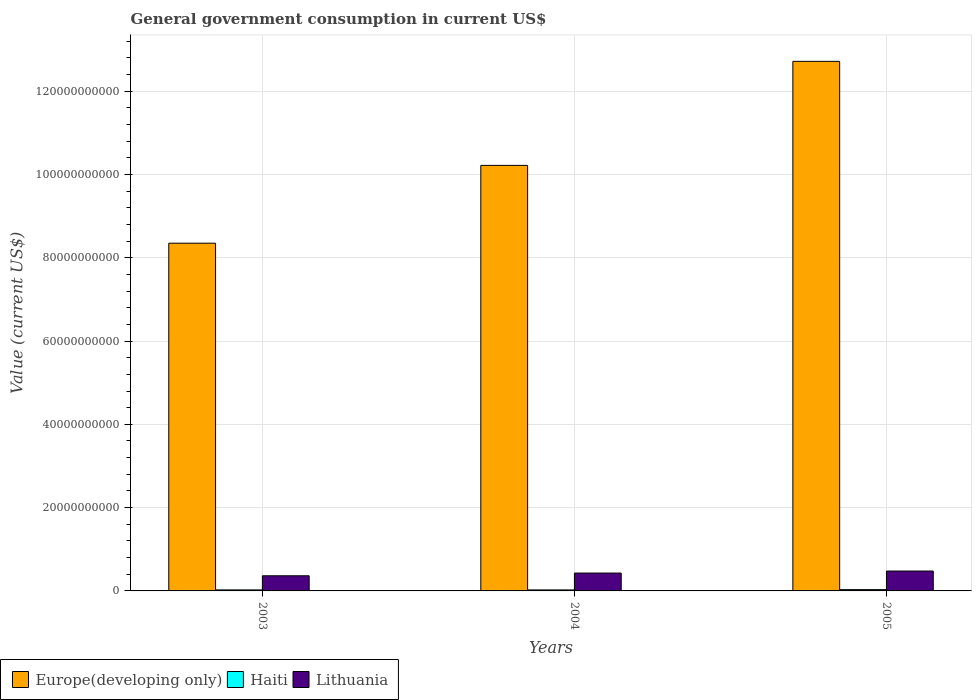How many different coloured bars are there?
Ensure brevity in your answer.  3. What is the government conusmption in Haiti in 2003?
Ensure brevity in your answer.  2.46e+08. Across all years, what is the maximum government conusmption in Europe(developing only)?
Your answer should be compact. 1.27e+11. Across all years, what is the minimum government conusmption in Lithuania?
Offer a terse response. 3.64e+09. In which year was the government conusmption in Europe(developing only) minimum?
Give a very brief answer. 2003. What is the total government conusmption in Lithuania in the graph?
Ensure brevity in your answer.  1.27e+1. What is the difference between the government conusmption in Europe(developing only) in 2003 and that in 2005?
Offer a terse response. -4.37e+1. What is the difference between the government conusmption in Haiti in 2005 and the government conusmption in Lithuania in 2003?
Your answer should be compact. -3.32e+09. What is the average government conusmption in Haiti per year?
Provide a succinct answer. 2.67e+08. In the year 2003, what is the difference between the government conusmption in Europe(developing only) and government conusmption in Lithuania?
Your answer should be very brief. 7.99e+1. In how many years, is the government conusmption in Europe(developing only) greater than 84000000000 US$?
Give a very brief answer. 2. What is the ratio of the government conusmption in Haiti in 2003 to that in 2004?
Your answer should be very brief. 1.02. Is the government conusmption in Haiti in 2004 less than that in 2005?
Your response must be concise. Yes. Is the difference between the government conusmption in Europe(developing only) in 2004 and 2005 greater than the difference between the government conusmption in Lithuania in 2004 and 2005?
Make the answer very short. No. What is the difference between the highest and the second highest government conusmption in Haiti?
Your answer should be very brief. 6.87e+07. What is the difference between the highest and the lowest government conusmption in Haiti?
Your answer should be compact. 7.45e+07. In how many years, is the government conusmption in Lithuania greater than the average government conusmption in Lithuania taken over all years?
Provide a short and direct response. 2. What does the 3rd bar from the left in 2005 represents?
Offer a very short reply. Lithuania. What does the 2nd bar from the right in 2003 represents?
Keep it short and to the point. Haiti. Is it the case that in every year, the sum of the government conusmption in Haiti and government conusmption in Europe(developing only) is greater than the government conusmption in Lithuania?
Provide a short and direct response. Yes. Are all the bars in the graph horizontal?
Make the answer very short. No. How many years are there in the graph?
Provide a succinct answer. 3. What is the difference between two consecutive major ticks on the Y-axis?
Your response must be concise. 2.00e+1. Are the values on the major ticks of Y-axis written in scientific E-notation?
Your response must be concise. No. Does the graph contain any zero values?
Offer a terse response. No. Does the graph contain grids?
Your answer should be compact. Yes. How many legend labels are there?
Offer a terse response. 3. What is the title of the graph?
Offer a terse response. General government consumption in current US$. Does "East Asia (all income levels)" appear as one of the legend labels in the graph?
Ensure brevity in your answer.  No. What is the label or title of the X-axis?
Provide a short and direct response. Years. What is the label or title of the Y-axis?
Keep it short and to the point. Value (current US$). What is the Value (current US$) in Europe(developing only) in 2003?
Your answer should be very brief. 8.35e+1. What is the Value (current US$) in Haiti in 2003?
Ensure brevity in your answer.  2.46e+08. What is the Value (current US$) in Lithuania in 2003?
Give a very brief answer. 3.64e+09. What is the Value (current US$) of Europe(developing only) in 2004?
Your response must be concise. 1.02e+11. What is the Value (current US$) in Haiti in 2004?
Your answer should be compact. 2.40e+08. What is the Value (current US$) in Lithuania in 2004?
Your answer should be compact. 4.29e+09. What is the Value (current US$) of Europe(developing only) in 2005?
Offer a terse response. 1.27e+11. What is the Value (current US$) in Haiti in 2005?
Offer a terse response. 3.15e+08. What is the Value (current US$) of Lithuania in 2005?
Offer a very short reply. 4.78e+09. Across all years, what is the maximum Value (current US$) in Europe(developing only)?
Make the answer very short. 1.27e+11. Across all years, what is the maximum Value (current US$) of Haiti?
Ensure brevity in your answer.  3.15e+08. Across all years, what is the maximum Value (current US$) in Lithuania?
Your answer should be very brief. 4.78e+09. Across all years, what is the minimum Value (current US$) in Europe(developing only)?
Offer a very short reply. 8.35e+1. Across all years, what is the minimum Value (current US$) of Haiti?
Offer a terse response. 2.40e+08. Across all years, what is the minimum Value (current US$) of Lithuania?
Keep it short and to the point. 3.64e+09. What is the total Value (current US$) in Europe(developing only) in the graph?
Provide a succinct answer. 3.13e+11. What is the total Value (current US$) in Haiti in the graph?
Make the answer very short. 8.01e+08. What is the total Value (current US$) in Lithuania in the graph?
Give a very brief answer. 1.27e+1. What is the difference between the Value (current US$) in Europe(developing only) in 2003 and that in 2004?
Offer a very short reply. -1.87e+1. What is the difference between the Value (current US$) of Haiti in 2003 and that in 2004?
Offer a terse response. 5.73e+06. What is the difference between the Value (current US$) of Lithuania in 2003 and that in 2004?
Offer a very short reply. -6.56e+08. What is the difference between the Value (current US$) in Europe(developing only) in 2003 and that in 2005?
Your response must be concise. -4.37e+1. What is the difference between the Value (current US$) in Haiti in 2003 and that in 2005?
Offer a very short reply. -6.87e+07. What is the difference between the Value (current US$) in Lithuania in 2003 and that in 2005?
Keep it short and to the point. -1.14e+09. What is the difference between the Value (current US$) of Europe(developing only) in 2004 and that in 2005?
Your answer should be very brief. -2.50e+1. What is the difference between the Value (current US$) in Haiti in 2004 and that in 2005?
Offer a very short reply. -7.45e+07. What is the difference between the Value (current US$) in Lithuania in 2004 and that in 2005?
Make the answer very short. -4.83e+08. What is the difference between the Value (current US$) in Europe(developing only) in 2003 and the Value (current US$) in Haiti in 2004?
Your answer should be very brief. 8.33e+1. What is the difference between the Value (current US$) in Europe(developing only) in 2003 and the Value (current US$) in Lithuania in 2004?
Ensure brevity in your answer.  7.92e+1. What is the difference between the Value (current US$) of Haiti in 2003 and the Value (current US$) of Lithuania in 2004?
Keep it short and to the point. -4.05e+09. What is the difference between the Value (current US$) of Europe(developing only) in 2003 and the Value (current US$) of Haiti in 2005?
Keep it short and to the point. 8.32e+1. What is the difference between the Value (current US$) of Europe(developing only) in 2003 and the Value (current US$) of Lithuania in 2005?
Your answer should be compact. 7.87e+1. What is the difference between the Value (current US$) of Haiti in 2003 and the Value (current US$) of Lithuania in 2005?
Offer a terse response. -4.53e+09. What is the difference between the Value (current US$) of Europe(developing only) in 2004 and the Value (current US$) of Haiti in 2005?
Your response must be concise. 1.02e+11. What is the difference between the Value (current US$) of Europe(developing only) in 2004 and the Value (current US$) of Lithuania in 2005?
Your answer should be compact. 9.74e+1. What is the difference between the Value (current US$) in Haiti in 2004 and the Value (current US$) in Lithuania in 2005?
Provide a short and direct response. -4.53e+09. What is the average Value (current US$) in Europe(developing only) per year?
Ensure brevity in your answer.  1.04e+11. What is the average Value (current US$) in Haiti per year?
Give a very brief answer. 2.67e+08. What is the average Value (current US$) in Lithuania per year?
Your response must be concise. 4.23e+09. In the year 2003, what is the difference between the Value (current US$) of Europe(developing only) and Value (current US$) of Haiti?
Your response must be concise. 8.33e+1. In the year 2003, what is the difference between the Value (current US$) of Europe(developing only) and Value (current US$) of Lithuania?
Provide a short and direct response. 7.99e+1. In the year 2003, what is the difference between the Value (current US$) in Haiti and Value (current US$) in Lithuania?
Your answer should be compact. -3.39e+09. In the year 2004, what is the difference between the Value (current US$) in Europe(developing only) and Value (current US$) in Haiti?
Give a very brief answer. 1.02e+11. In the year 2004, what is the difference between the Value (current US$) in Europe(developing only) and Value (current US$) in Lithuania?
Your response must be concise. 9.79e+1. In the year 2004, what is the difference between the Value (current US$) of Haiti and Value (current US$) of Lithuania?
Your answer should be very brief. -4.05e+09. In the year 2005, what is the difference between the Value (current US$) of Europe(developing only) and Value (current US$) of Haiti?
Provide a succinct answer. 1.27e+11. In the year 2005, what is the difference between the Value (current US$) in Europe(developing only) and Value (current US$) in Lithuania?
Keep it short and to the point. 1.22e+11. In the year 2005, what is the difference between the Value (current US$) of Haiti and Value (current US$) of Lithuania?
Keep it short and to the point. -4.46e+09. What is the ratio of the Value (current US$) of Europe(developing only) in 2003 to that in 2004?
Your answer should be very brief. 0.82. What is the ratio of the Value (current US$) in Haiti in 2003 to that in 2004?
Keep it short and to the point. 1.02. What is the ratio of the Value (current US$) in Lithuania in 2003 to that in 2004?
Make the answer very short. 0.85. What is the ratio of the Value (current US$) of Europe(developing only) in 2003 to that in 2005?
Keep it short and to the point. 0.66. What is the ratio of the Value (current US$) of Haiti in 2003 to that in 2005?
Provide a short and direct response. 0.78. What is the ratio of the Value (current US$) of Lithuania in 2003 to that in 2005?
Ensure brevity in your answer.  0.76. What is the ratio of the Value (current US$) in Europe(developing only) in 2004 to that in 2005?
Make the answer very short. 0.8. What is the ratio of the Value (current US$) of Haiti in 2004 to that in 2005?
Give a very brief answer. 0.76. What is the ratio of the Value (current US$) of Lithuania in 2004 to that in 2005?
Offer a terse response. 0.9. What is the difference between the highest and the second highest Value (current US$) of Europe(developing only)?
Your answer should be very brief. 2.50e+1. What is the difference between the highest and the second highest Value (current US$) in Haiti?
Your response must be concise. 6.87e+07. What is the difference between the highest and the second highest Value (current US$) in Lithuania?
Your answer should be very brief. 4.83e+08. What is the difference between the highest and the lowest Value (current US$) in Europe(developing only)?
Make the answer very short. 4.37e+1. What is the difference between the highest and the lowest Value (current US$) in Haiti?
Provide a short and direct response. 7.45e+07. What is the difference between the highest and the lowest Value (current US$) of Lithuania?
Give a very brief answer. 1.14e+09. 